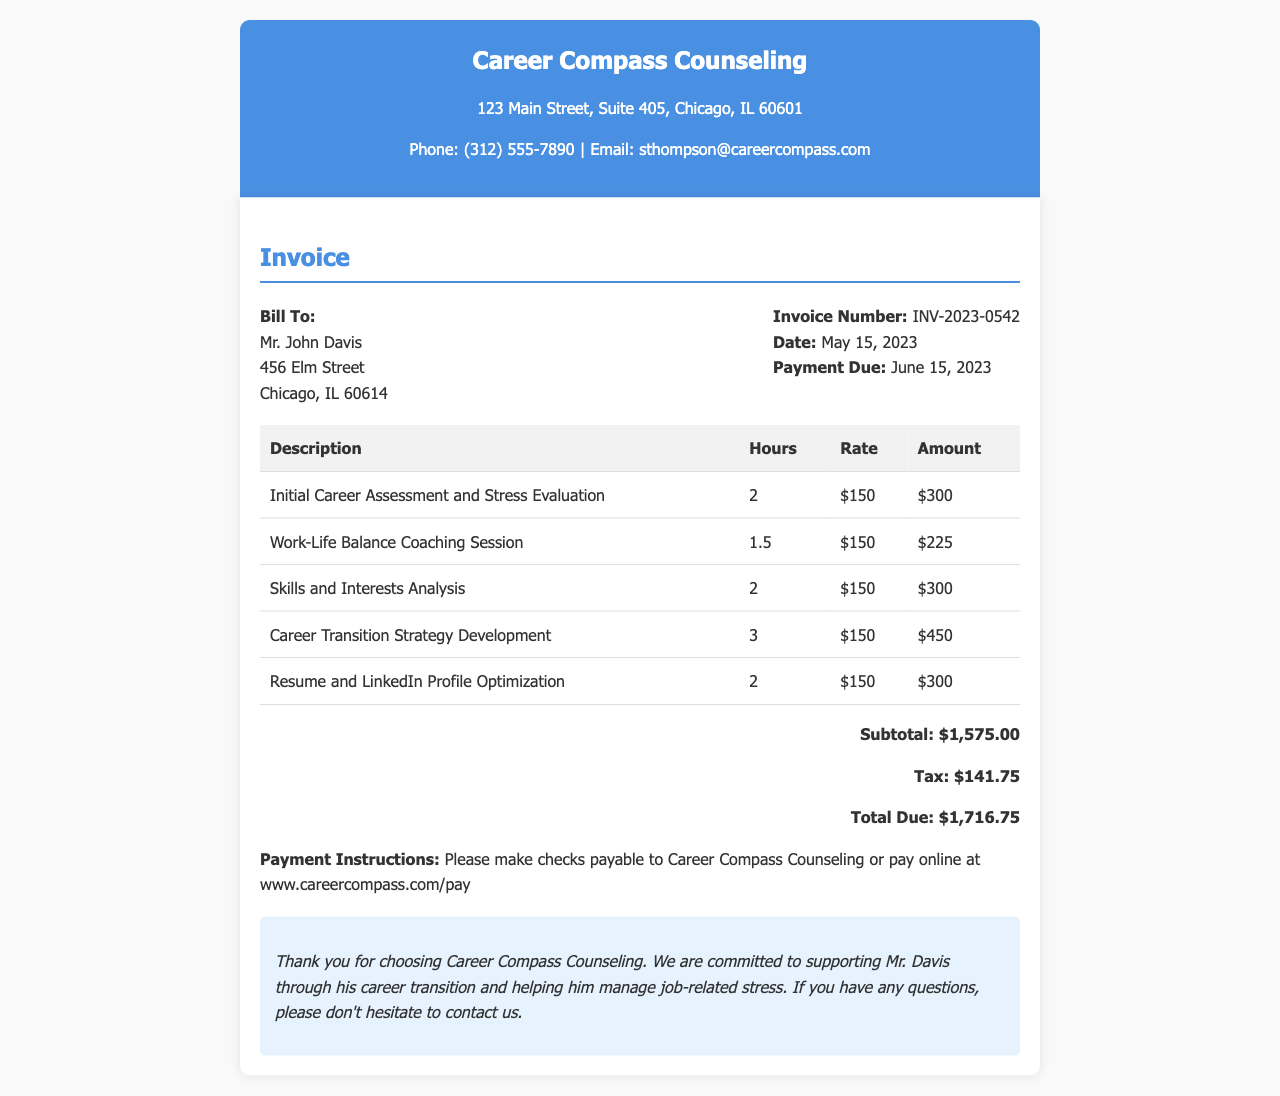What is the name of the counseling service? The name of the counseling service is mentioned in the header of the document as Career Compass Counseling.
Answer: Career Compass Counseling Who is the invoice billed to? The document specifies that the invoice is billed to Mr. John Davis.
Answer: Mr. John Davis What is the invoice number? The invoice number is indicated in the document and is INV-2023-0542.
Answer: INV-2023-0542 What is the date of the invoice? The document lists the date of the invoice as May 15, 2023.
Answer: May 15, 2023 What is the total amount due? The total amount due is calculated and shown in the document as $1,716.75.
Answer: $1,716.75 How many hours were spent on the Career Transition Strategy Development? The document states that 3 hours were spent on the Career Transition Strategy Development.
Answer: 3 What service had the highest individual charge? The service with the highest individual charge in the document is Career Transition Strategy Development at $450.
Answer: Career Transition Strategy Development What payment methods are mentioned in the document? The document provides payment instructions indicating two methods: by check or online payment.
Answer: Check or online payment What is the tax amount included in the invoice? The tax amount is mentioned in the document as $141.75.
Answer: $141.75 